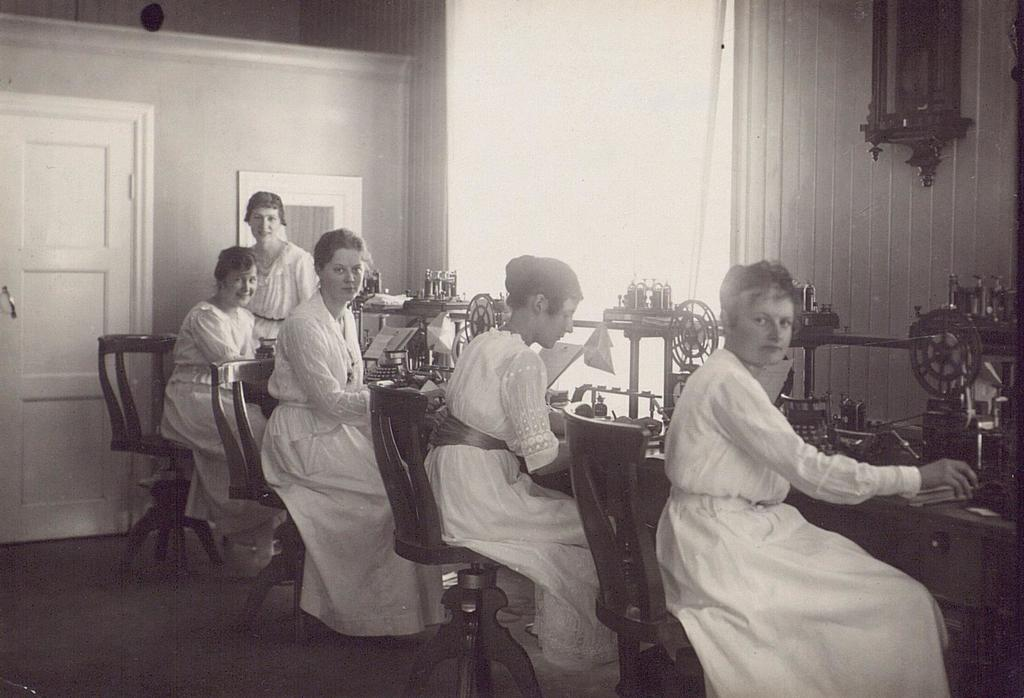What are the people in the image doing? The people in the image are sitting. What furniture can be seen in the image? There are chairs in the image. What objects are on the table and floor in the image? There is a machine on a table and a machine on the floor. What can be seen in the background of the image? There is a wall, a door, and a frame in the background of the image. Can you see a yak in the image? No, there is no yak present in the image. What color is the kitty sitting on the chair? There is no kitty present in the image. 